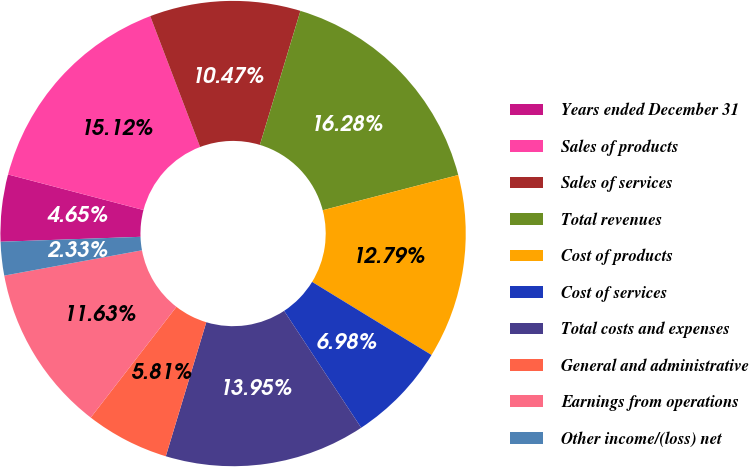Convert chart to OTSL. <chart><loc_0><loc_0><loc_500><loc_500><pie_chart><fcel>Years ended December 31<fcel>Sales of products<fcel>Sales of services<fcel>Total revenues<fcel>Cost of products<fcel>Cost of services<fcel>Total costs and expenses<fcel>General and administrative<fcel>Earnings from operations<fcel>Other income/(loss) net<nl><fcel>4.65%<fcel>15.12%<fcel>10.47%<fcel>16.28%<fcel>12.79%<fcel>6.98%<fcel>13.95%<fcel>5.81%<fcel>11.63%<fcel>2.33%<nl></chart> 